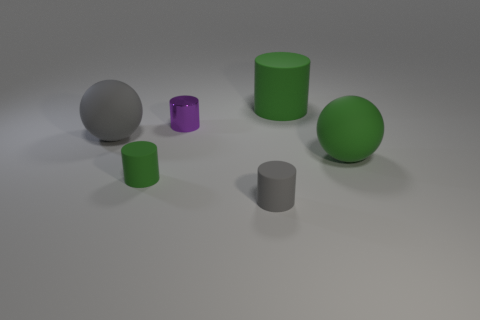Subtract all gray matte cylinders. How many cylinders are left? 3 Add 4 purple metallic cylinders. How many objects exist? 10 Subtract all purple cylinders. How many cylinders are left? 3 Subtract 1 cylinders. How many cylinders are left? 3 Subtract all spheres. How many objects are left? 4 Subtract all gray cylinders. Subtract all yellow spheres. How many cylinders are left? 3 Subtract all yellow blocks. How many green cylinders are left? 2 Subtract all purple metallic cylinders. Subtract all purple cylinders. How many objects are left? 4 Add 1 large green matte objects. How many large green matte objects are left? 3 Add 4 purple shiny cylinders. How many purple shiny cylinders exist? 5 